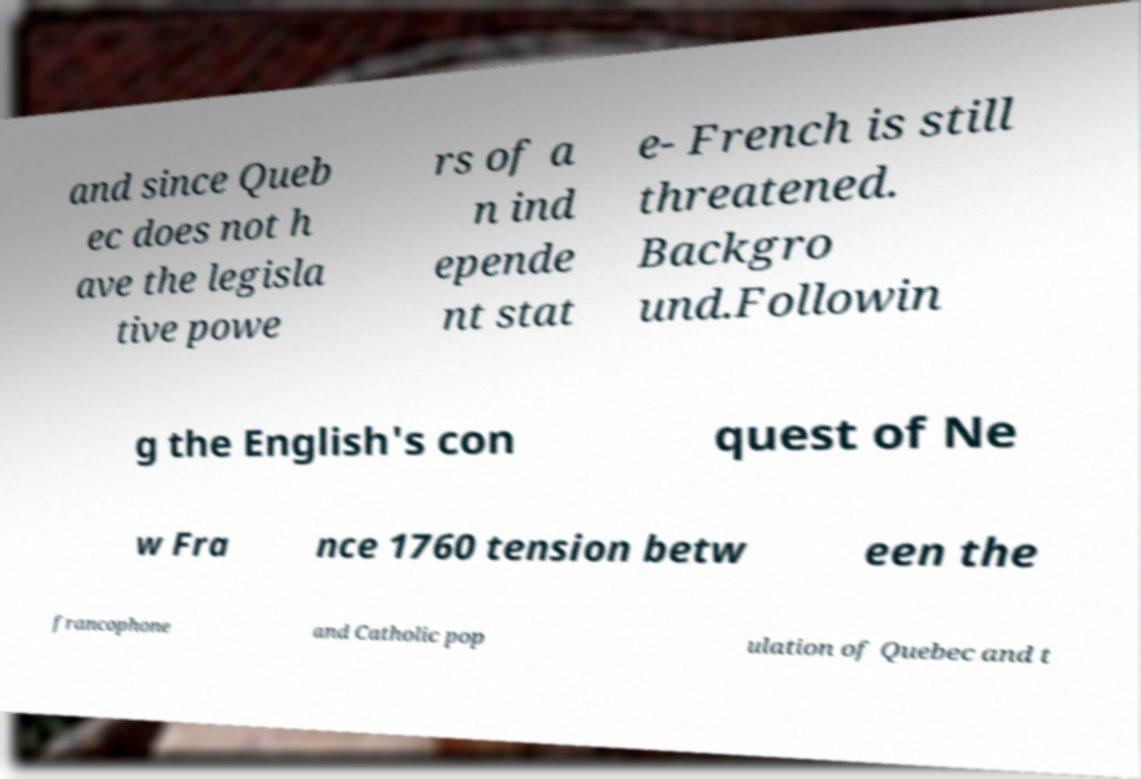Could you assist in decoding the text presented in this image and type it out clearly? and since Queb ec does not h ave the legisla tive powe rs of a n ind epende nt stat e- French is still threatened. Backgro und.Followin g the English's con quest of Ne w Fra nce 1760 tension betw een the francophone and Catholic pop ulation of Quebec and t 